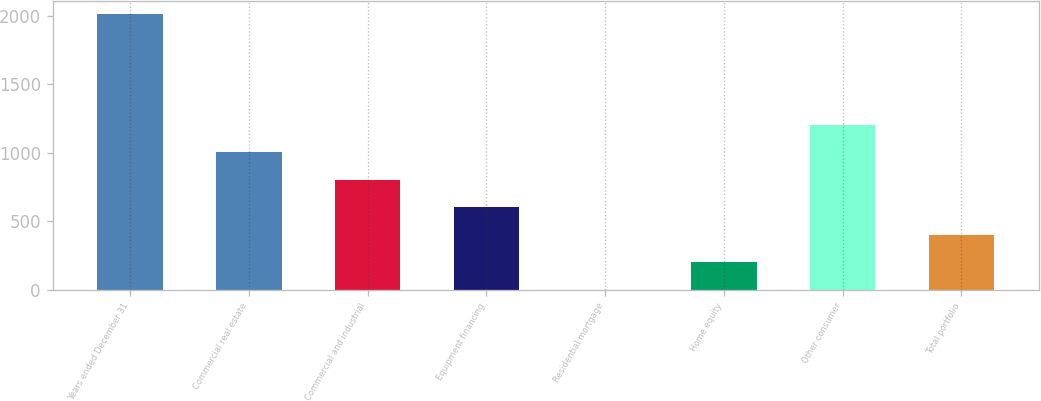<chart> <loc_0><loc_0><loc_500><loc_500><bar_chart><fcel>Years ended December 31<fcel>Commercial real estate<fcel>Commercial and industrial<fcel>Equipment financing<fcel>Residential mortgage<fcel>Home equity<fcel>Other consumer<fcel>Total portfolio<nl><fcel>2010<fcel>1005.09<fcel>804.1<fcel>603.11<fcel>0.15<fcel>201.14<fcel>1206.08<fcel>402.12<nl></chart> 